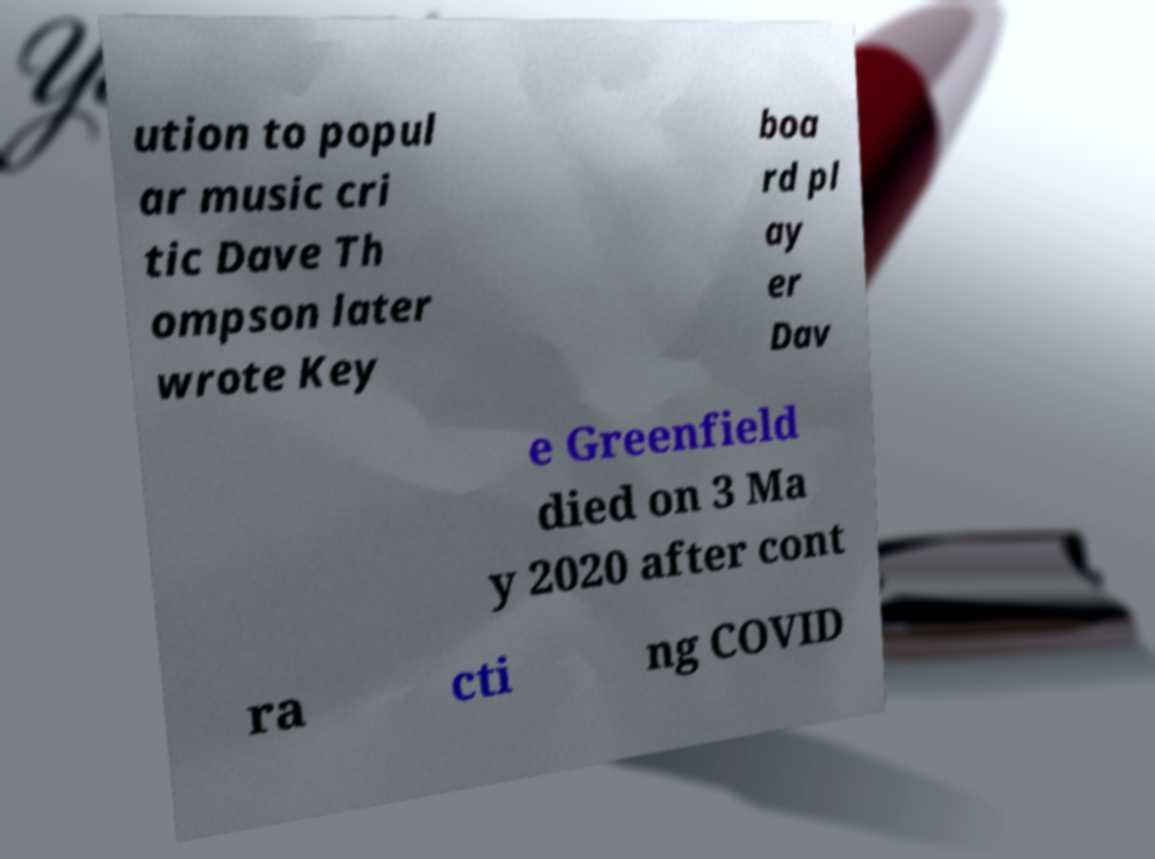Can you accurately transcribe the text from the provided image for me? ution to popul ar music cri tic Dave Th ompson later wrote Key boa rd pl ay er Dav e Greenfield died on 3 Ma y 2020 after cont ra cti ng COVID 